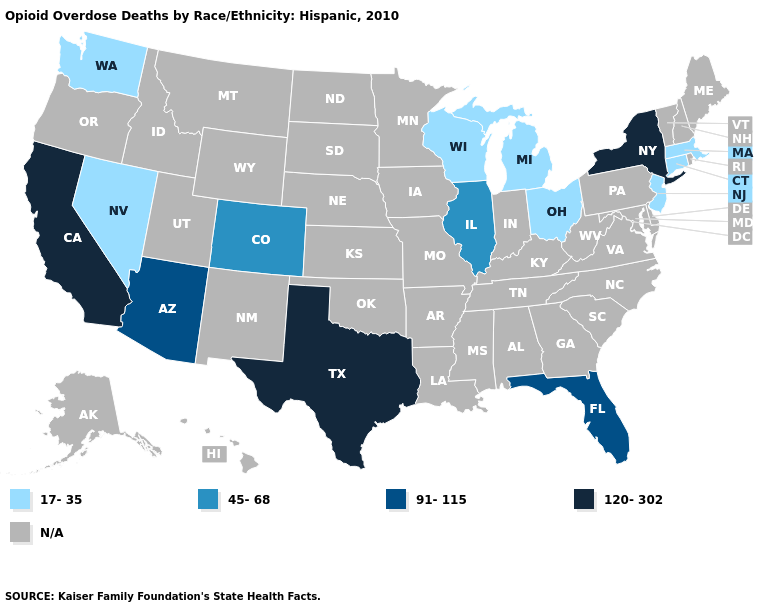Which states have the lowest value in the Northeast?
Write a very short answer. Connecticut, Massachusetts, New Jersey. What is the value of Montana?
Write a very short answer. N/A. Does Massachusetts have the highest value in the USA?
Write a very short answer. No. What is the highest value in states that border Louisiana?
Write a very short answer. 120-302. What is the value of Florida?
Short answer required. 91-115. Name the states that have a value in the range 17-35?
Give a very brief answer. Connecticut, Massachusetts, Michigan, Nevada, New Jersey, Ohio, Washington, Wisconsin. Among the states that border Minnesota , which have the lowest value?
Keep it brief. Wisconsin. What is the highest value in the South ?
Give a very brief answer. 120-302. Which states have the lowest value in the USA?
Short answer required. Connecticut, Massachusetts, Michigan, Nevada, New Jersey, Ohio, Washington, Wisconsin. Among the states that border Pennsylvania , which have the lowest value?
Concise answer only. New Jersey, Ohio. Does New York have the lowest value in the USA?
Answer briefly. No. Name the states that have a value in the range N/A?
Give a very brief answer. Alabama, Alaska, Arkansas, Delaware, Georgia, Hawaii, Idaho, Indiana, Iowa, Kansas, Kentucky, Louisiana, Maine, Maryland, Minnesota, Mississippi, Missouri, Montana, Nebraska, New Hampshire, New Mexico, North Carolina, North Dakota, Oklahoma, Oregon, Pennsylvania, Rhode Island, South Carolina, South Dakota, Tennessee, Utah, Vermont, Virginia, West Virginia, Wyoming. Which states hav the highest value in the South?
Keep it brief. Texas. Is the legend a continuous bar?
Answer briefly. No. 